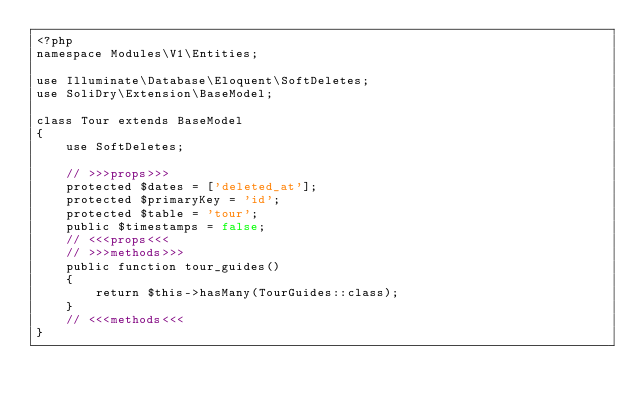<code> <loc_0><loc_0><loc_500><loc_500><_PHP_><?php
namespace Modules\V1\Entities;

use Illuminate\Database\Eloquent\SoftDeletes;
use SoliDry\Extension\BaseModel;

class Tour extends BaseModel
{
    use SoftDeletes;

    // >>>props>>>
    protected $dates = ['deleted_at'];
    protected $primaryKey = 'id';
    protected $table = 'tour';
    public $timestamps = false;
    // <<<props<<<
    // >>>methods>>>
    public function tour_guides()
    {
        return $this->hasMany(TourGuides::class);
    }
    // <<<methods<<<
}
</code> 